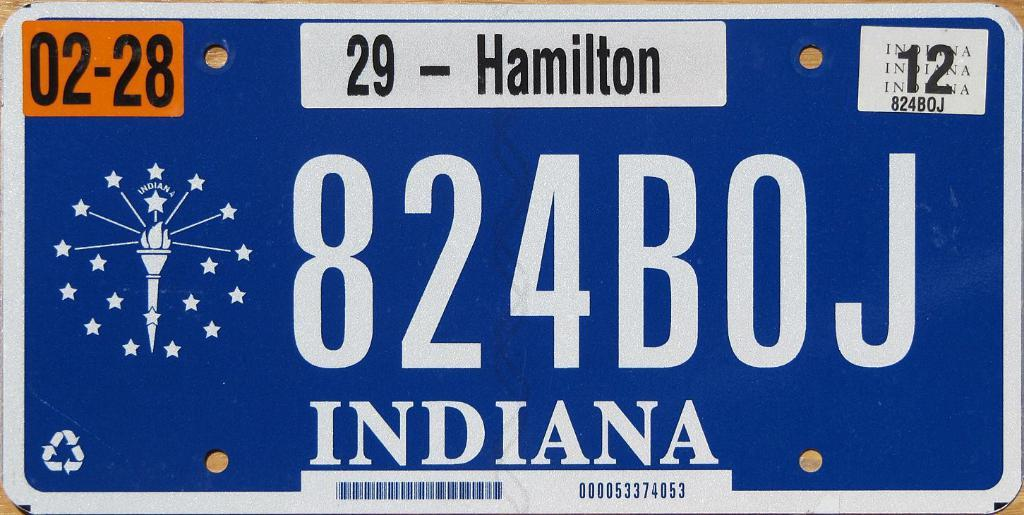<image>
Create a compact narrative representing the image presented. the state of Indiana is on a license plate 